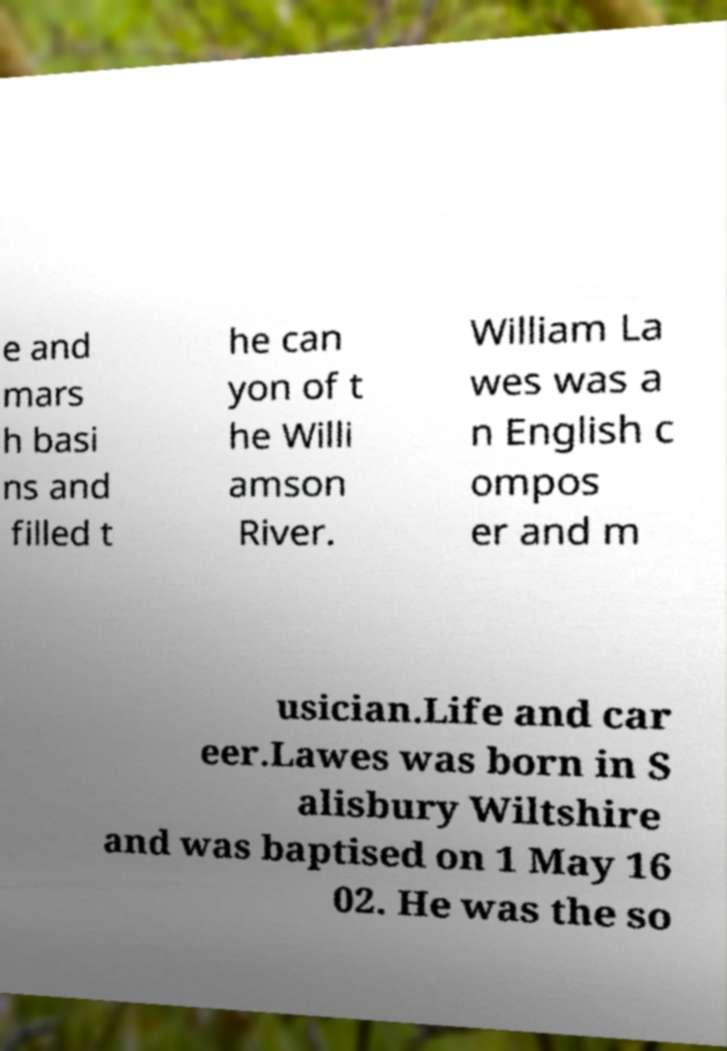Could you assist in decoding the text presented in this image and type it out clearly? e and mars h basi ns and filled t he can yon of t he Willi amson River. William La wes was a n English c ompos er and m usician.Life and car eer.Lawes was born in S alisbury Wiltshire and was baptised on 1 May 16 02. He was the so 